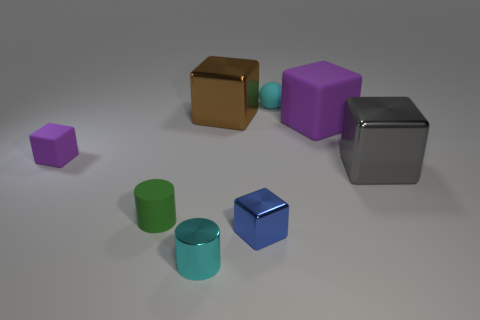The tiny shiny object that is the same color as the small matte ball is what shape?
Ensure brevity in your answer.  Cylinder. Do the gray metal block and the cylinder that is right of the small rubber cylinder have the same size?
Your answer should be compact. No. What is the shape of the tiny cyan object that is in front of the big gray object?
Provide a succinct answer. Cylinder. There is a big metallic block that is in front of the rubber block on the left side of the rubber sphere; what is its color?
Your answer should be compact. Gray. What color is the other large matte object that is the same shape as the blue thing?
Your answer should be compact. Purple. How many objects are the same color as the tiny rubber ball?
Keep it short and to the point. 1. Is the color of the large matte thing the same as the metallic cube that is to the left of the small metallic block?
Keep it short and to the point. No. What is the shape of the thing that is both to the right of the brown thing and behind the big purple matte object?
Offer a very short reply. Sphere. The cyan thing in front of the rubber block that is on the right side of the tiny cyan thing that is in front of the gray cube is made of what material?
Make the answer very short. Metal. Is the number of tiny purple blocks in front of the gray metallic thing greater than the number of big brown shiny objects that are right of the brown metal cube?
Give a very brief answer. No. 